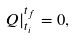<formula> <loc_0><loc_0><loc_500><loc_500>Q | _ { t _ { i } } ^ { t _ { f } } = 0 ,</formula> 